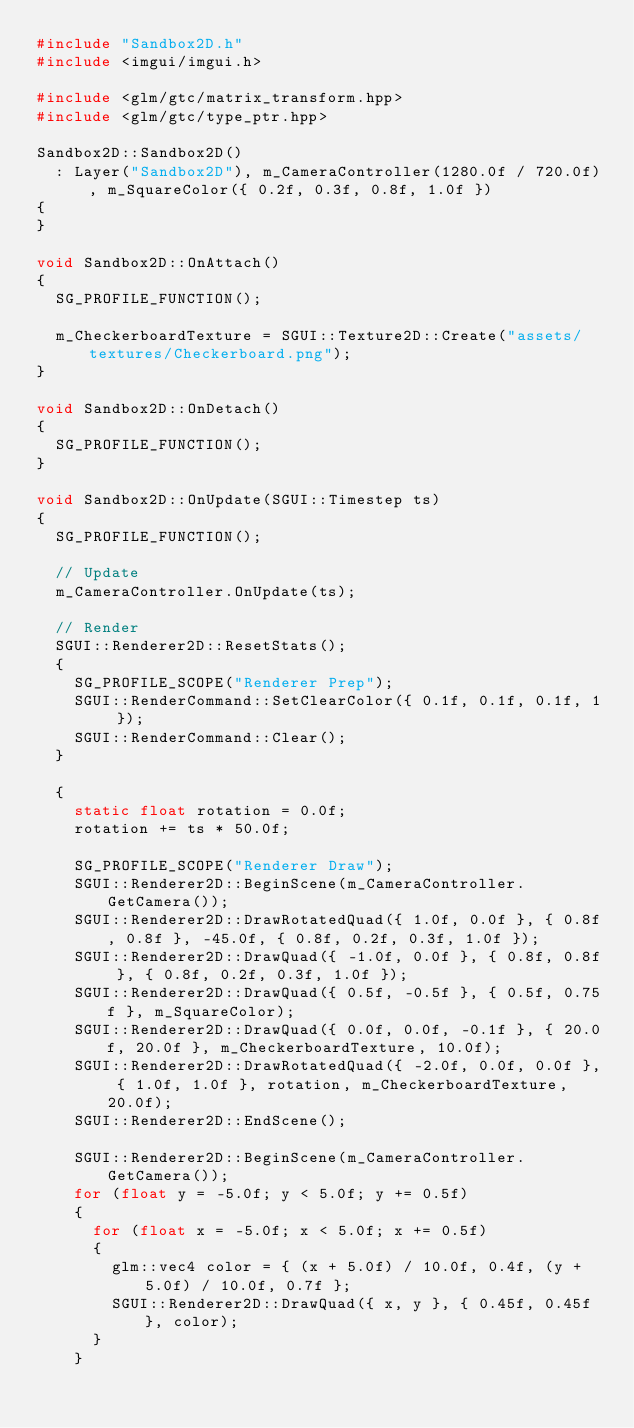<code> <loc_0><loc_0><loc_500><loc_500><_C++_>#include "Sandbox2D.h"
#include <imgui/imgui.h>

#include <glm/gtc/matrix_transform.hpp>
#include <glm/gtc/type_ptr.hpp>

Sandbox2D::Sandbox2D()
	: Layer("Sandbox2D"), m_CameraController(1280.0f / 720.0f), m_SquareColor({ 0.2f, 0.3f, 0.8f, 1.0f })
{
}

void Sandbox2D::OnAttach()
{
	SG_PROFILE_FUNCTION();

	m_CheckerboardTexture = SGUI::Texture2D::Create("assets/textures/Checkerboard.png");
}

void Sandbox2D::OnDetach()
{
	SG_PROFILE_FUNCTION();
}

void Sandbox2D::OnUpdate(SGUI::Timestep ts)
{
	SG_PROFILE_FUNCTION();

	// Update
	m_CameraController.OnUpdate(ts);

	// Render
	SGUI::Renderer2D::ResetStats();
	{
		SG_PROFILE_SCOPE("Renderer Prep");
		SGUI::RenderCommand::SetClearColor({ 0.1f, 0.1f, 0.1f, 1 });
		SGUI::RenderCommand::Clear();
	}

	{
		static float rotation = 0.0f;
		rotation += ts * 50.0f;

		SG_PROFILE_SCOPE("Renderer Draw");
		SGUI::Renderer2D::BeginScene(m_CameraController.GetCamera());
		SGUI::Renderer2D::DrawRotatedQuad({ 1.0f, 0.0f }, { 0.8f, 0.8f }, -45.0f, { 0.8f, 0.2f, 0.3f, 1.0f });
		SGUI::Renderer2D::DrawQuad({ -1.0f, 0.0f }, { 0.8f, 0.8f }, { 0.8f, 0.2f, 0.3f, 1.0f });
		SGUI::Renderer2D::DrawQuad({ 0.5f, -0.5f }, { 0.5f, 0.75f }, m_SquareColor);
		SGUI::Renderer2D::DrawQuad({ 0.0f, 0.0f, -0.1f }, { 20.0f, 20.0f }, m_CheckerboardTexture, 10.0f);
		SGUI::Renderer2D::DrawRotatedQuad({ -2.0f, 0.0f, 0.0f }, { 1.0f, 1.0f }, rotation, m_CheckerboardTexture, 20.0f);
		SGUI::Renderer2D::EndScene();

		SGUI::Renderer2D::BeginScene(m_CameraController.GetCamera());
		for (float y = -5.0f; y < 5.0f; y += 0.5f)
		{
			for (float x = -5.0f; x < 5.0f; x += 0.5f)
			{
				glm::vec4 color = { (x + 5.0f) / 10.0f, 0.4f, (y + 5.0f) / 10.0f, 0.7f };
				SGUI::Renderer2D::DrawQuad({ x, y }, { 0.45f, 0.45f }, color);
			}
		}</code> 